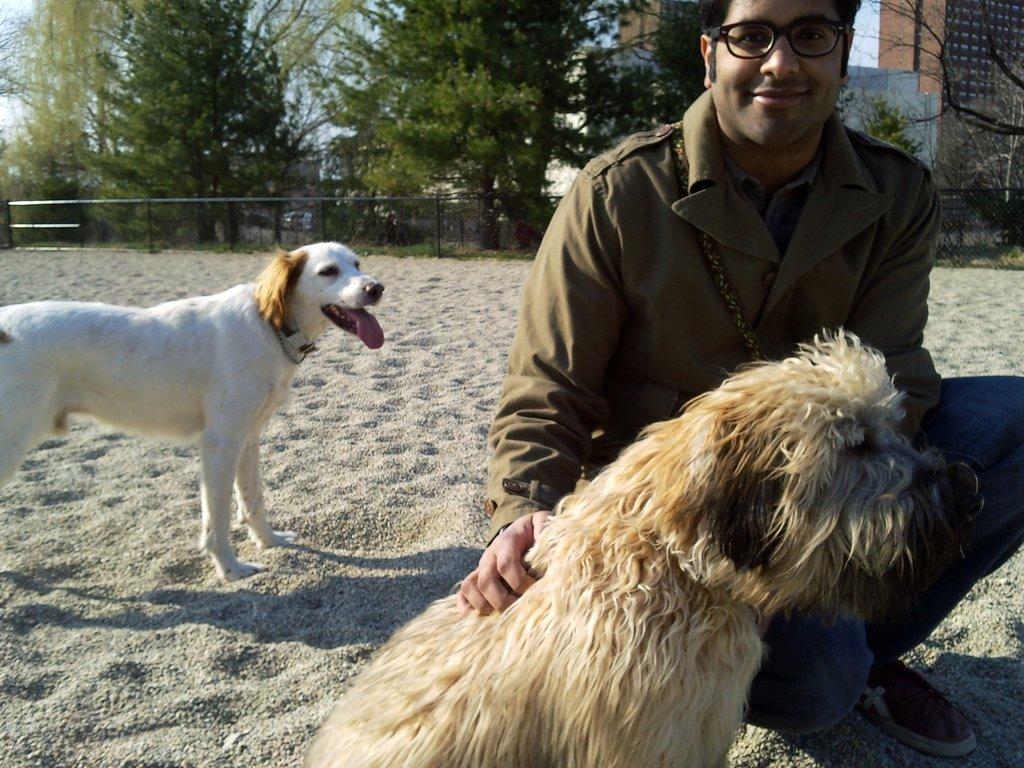Could you give a brief overview of what you see in this image? In this picture I can see two dogs and a man. The man is wearing a spectacle, a coat, jeans and shoes. In the background I can see a fence, buildings, trees and the sky. 